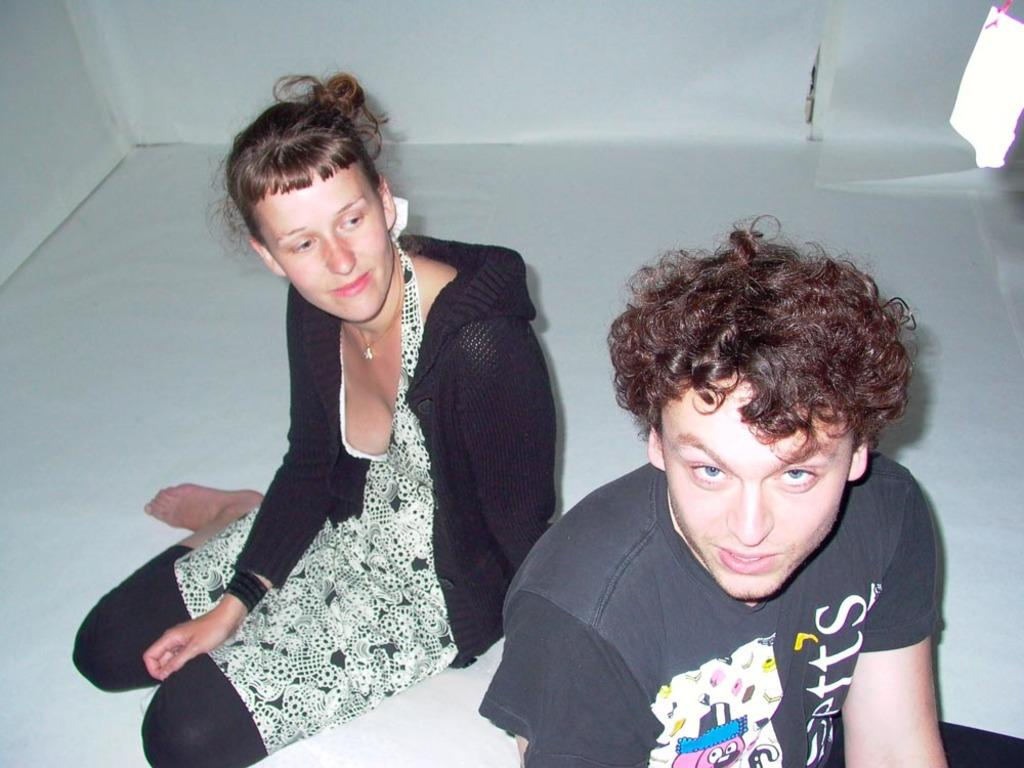How many people are sitting on the floor in the image? There are two persons sitting on the floor in the image. What can be seen in the background of the image? There is a wall in the background of the image. How many cakes are being shared by the two persons sitting on the floor in the image? There is no mention of cakes in the image, so we cannot determine how many cakes are being shared. 